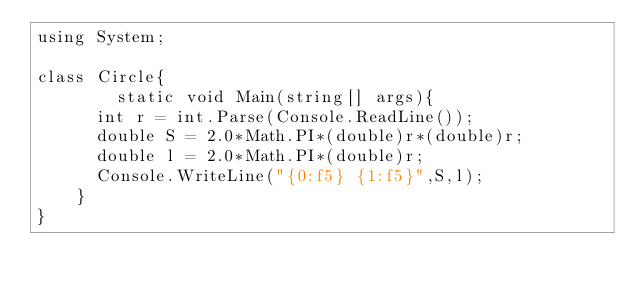Convert code to text. <code><loc_0><loc_0><loc_500><loc_500><_C#_>using System;

class Circle{
        static void Main(string[] args){
	  int r = int.Parse(Console.ReadLine());
	  double S = 2.0*Math.PI*(double)r*(double)r;
	  double l = 2.0*Math.PI*(double)r;
	  Console.WriteLine("{0:f5} {1:f5}",S,l);
	}
}</code> 